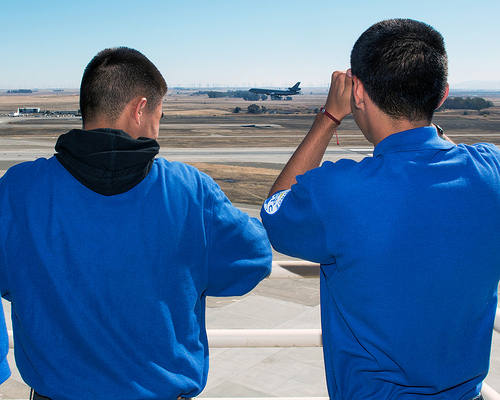<image>
Is there a flight on the man? No. The flight is not positioned on the man. They may be near each other, but the flight is not supported by or resting on top of the man. Is there a blue shirt next to the man? Yes. The blue shirt is positioned adjacent to the man, located nearby in the same general area. 